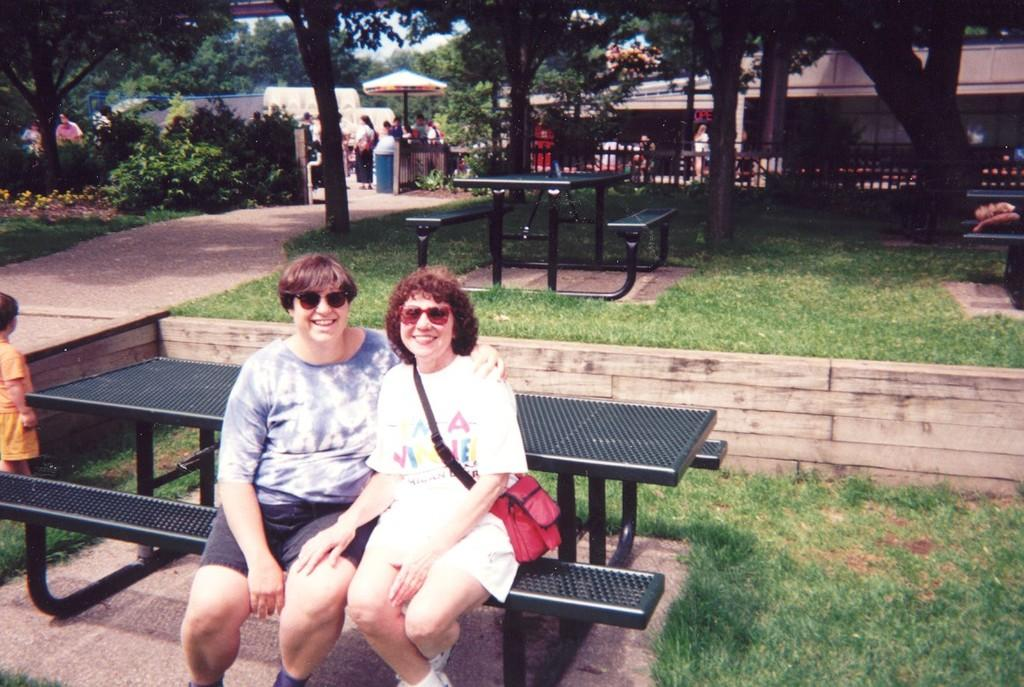How many people are sitting on a bench in the image? There are two persons sitting on a bench in the image. Can you describe the setting of the image? The image features people sitting on a bench, surrounded by grass, trees, and plants. Are there any other benches visible in the image? Yes, there are additional benches in the image. What is the person sitting on the bench in the image interested in? The provided facts do not give any information about the interests of the person sitting on the bench in the image. --- Facts: 1. There is a car in the image. 2. The car is parked on the street. 3. There are buildings in the background of the image. 4. The sky is visible in the image. 5. There are streetlights present in the image. Absurd Topics: parrot, dance, ocean Conversation: What type of vehicle is visible in the image? There is a car in the image. Where is the car located in the image? The car is parked on the street in the image. What can be seen in the background of the image? There are buildings in the background of the image. What is visible at the top of the image? The sky is visible in the image. What type of lighting is present in the image? There are streetlights present in the image. Reasoning: Let's think step by step in order to produce the conversation. We start by identifying the main subject in the image, which is the car. Then, we expand the conversation to include the location of the car, the background, the sky, and the streetlights. Each question is designed to elicit a specific detail about the image that is known from the provided facts. Absurd Question/Answer: Can you see a parrot dancing near the car in the image? No, there is no parrot or dancing activity present in the image. --- Facts: 1. There is a person holding a 